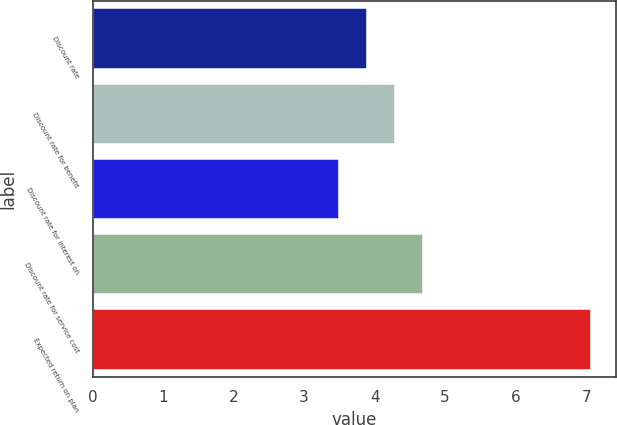<chart> <loc_0><loc_0><loc_500><loc_500><bar_chart><fcel>Discount rate<fcel>Discount rate for benefit<fcel>Discount rate for interest on<fcel>Discount rate for service cost<fcel>Expected return on plan<nl><fcel>3.89<fcel>4.29<fcel>3.49<fcel>4.69<fcel>7.07<nl></chart> 